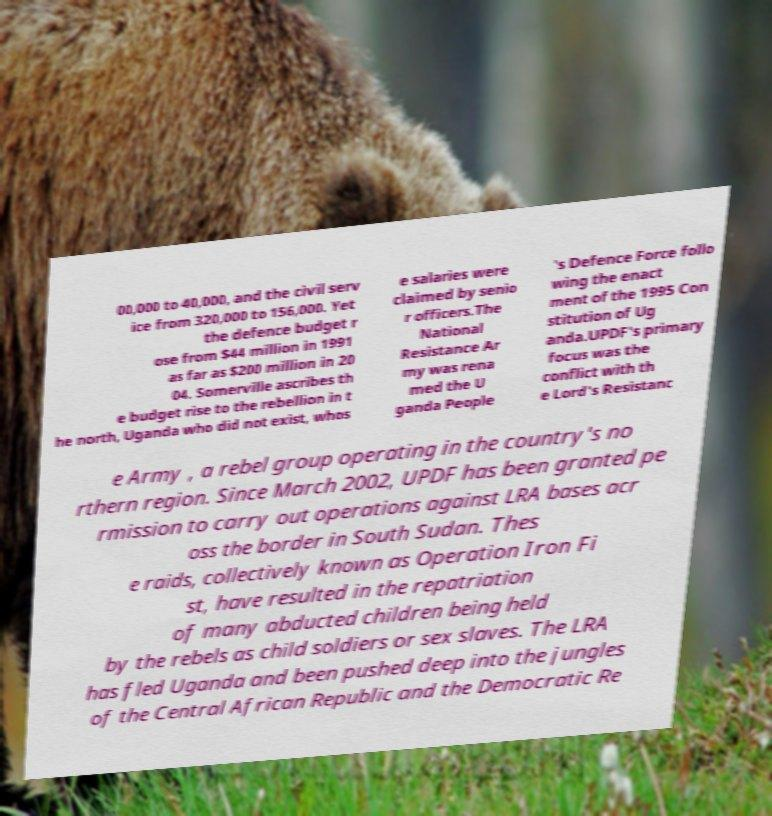Could you assist in decoding the text presented in this image and type it out clearly? 00,000 to 40,000, and the civil serv ice from 320,000 to 156,000. Yet the defence budget r ose from $44 million in 1991 as far as $200 million in 20 04. Somerville ascribes th e budget rise to the rebellion in t he north, Uganda who did not exist, whos e salaries were claimed by senio r officers.The National Resistance Ar my was rena med the U ganda People 's Defence Force follo wing the enact ment of the 1995 Con stitution of Ug anda.UPDF's primary focus was the conflict with th e Lord's Resistanc e Army , a rebel group operating in the country's no rthern region. Since March 2002, UPDF has been granted pe rmission to carry out operations against LRA bases acr oss the border in South Sudan. Thes e raids, collectively known as Operation Iron Fi st, have resulted in the repatriation of many abducted children being held by the rebels as child soldiers or sex slaves. The LRA has fled Uganda and been pushed deep into the jungles of the Central African Republic and the Democratic Re 